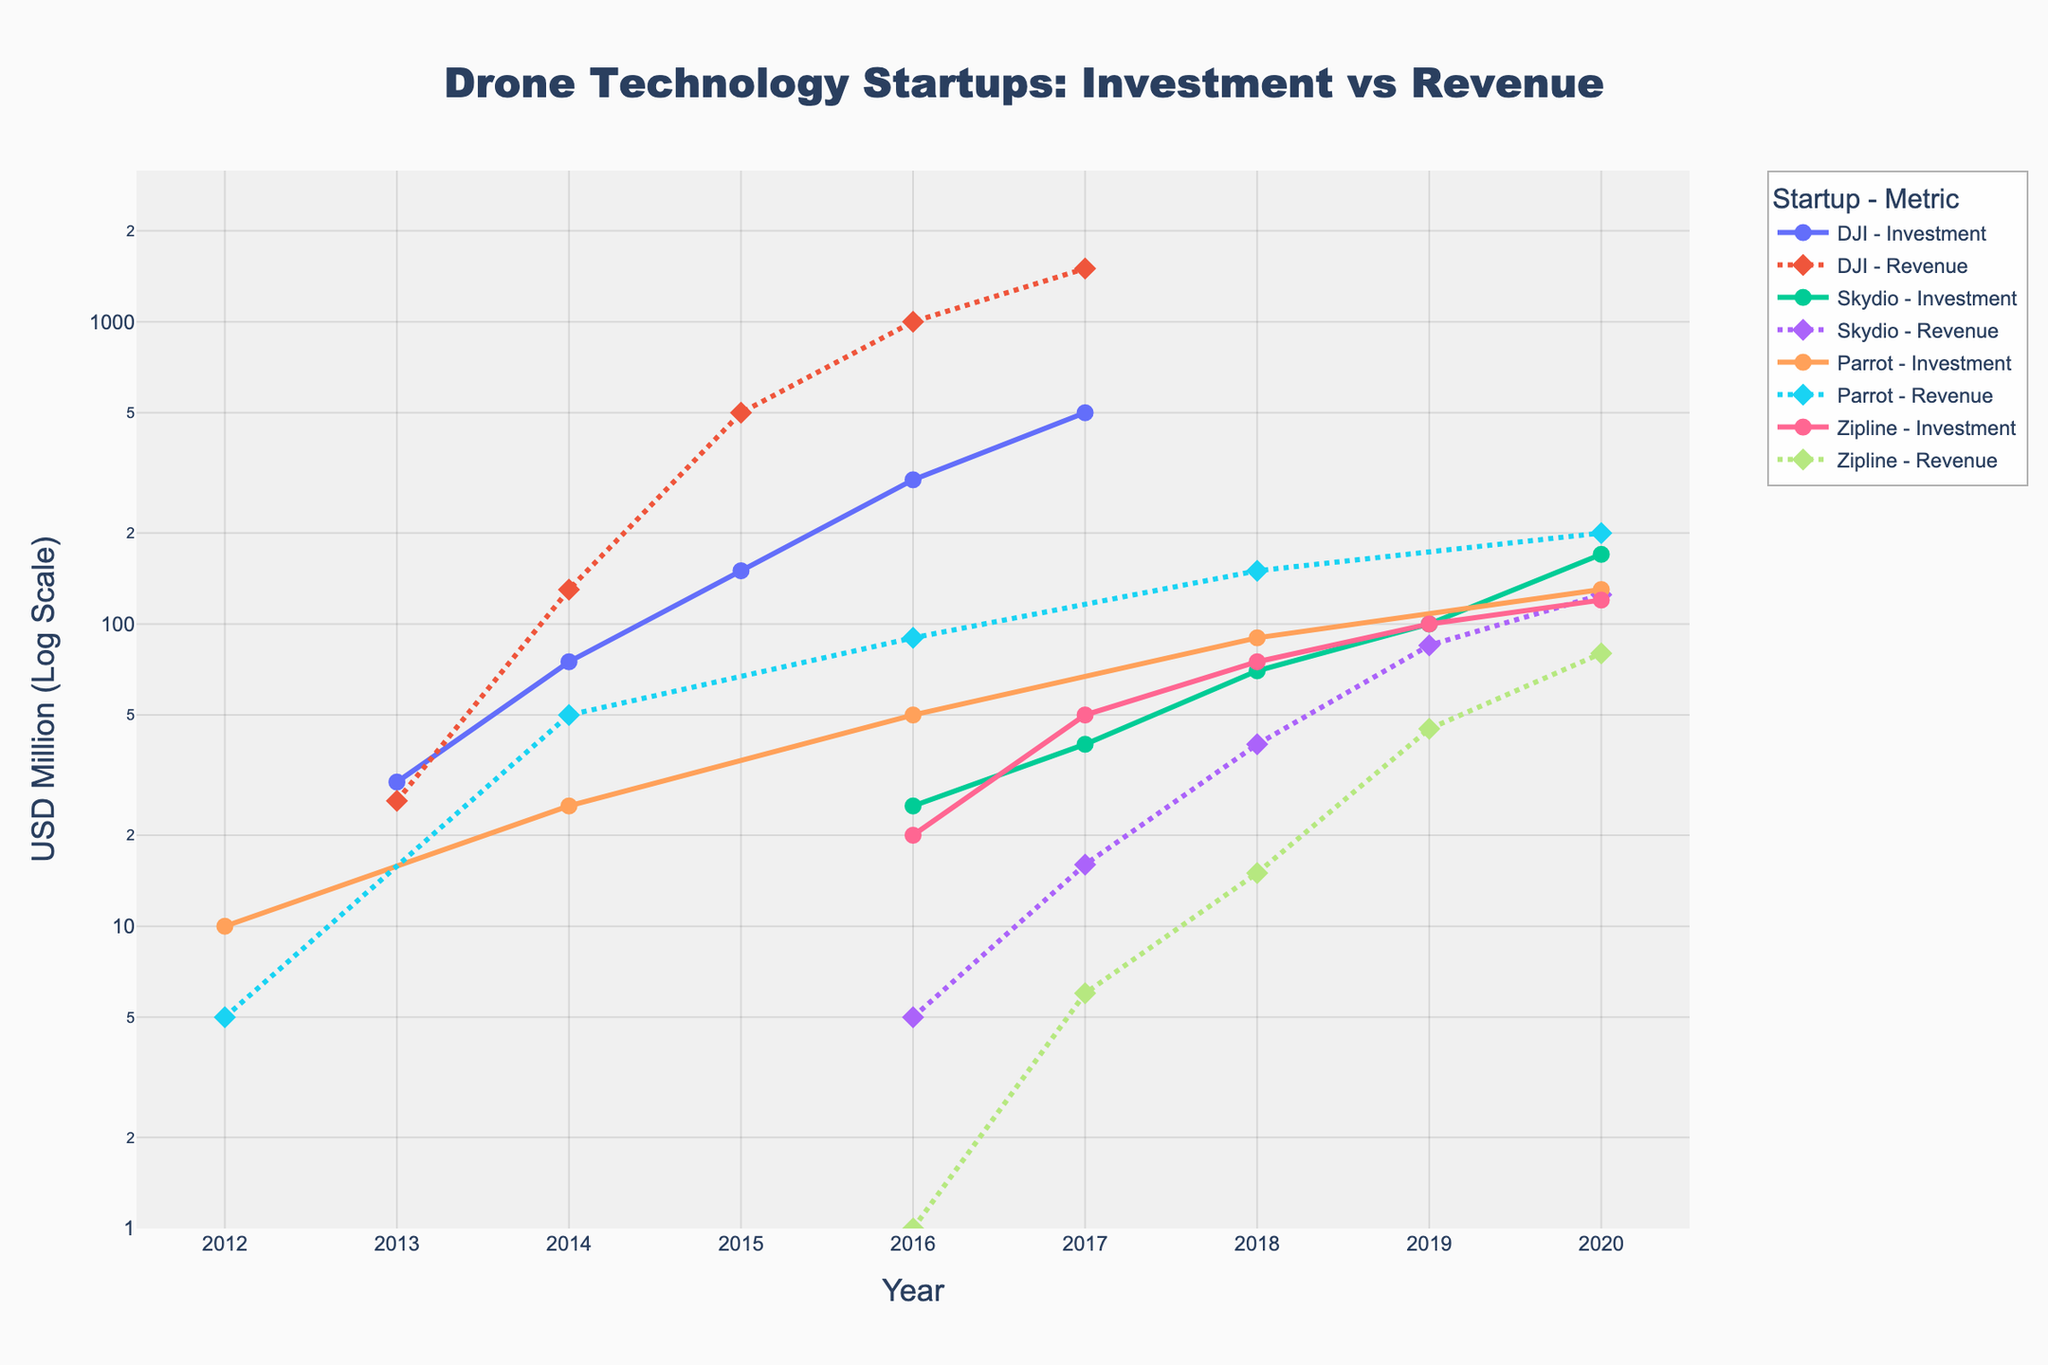what is the title of the plot? The title is displayed at the top of the plot in large, bold text. It reads "Drone Technology Startups: Investment vs Revenue".
Answer: Drone Technology Startups: Investment vs Revenue what is the y-axis label of the plot? The y-axis label is shown vertically along the y-axis and it reads "USD Million (Log Scale)".
Answer: USD Million (Log Scale) which startup had the highest investment in the year 2017? From the plot, looking at the investment lines for each startup, DJI had the highest investment in 2017, indicated by the data point at $500 million.
Answer: DJI how has Skydio's revenue changed from 2016 to 2020? By examining the dashed lines for Skydio, we see that it increased from $5 million in 2016 to $125 million in 2020. The line trends upwards significantly between these years.
Answer: Increased from $5 million to $125 million which startup showed the steadiest growth in both investment and revenue over the years? Observing the smoothness and consistency of the lines for both investment and revenue, Parrot's lines are the most consistent without significant jumps or drops over the years.
Answer: Parrot in what year did Zipline's revenue first exceed $10 million? By looking at the dashed line for Zipline, its revenue first exceeded $10 million in 2018.
Answer: 2018 how did DJI's investment trend between 2013 and 2017? Looking at the solid line for DJI, the investment shows a mostly exponential increase from $30 million in 2013 to $500 million in 2017.
Answer: Exponential increase compare the investment of Skydio and Parrot in 2016. Which startup received more investment, and by how much? Observing the solid lines for 2016, Skydio received $25 million and Parrot received $50 million. Parrot received $25 million more investment than Skydio in 2016.
Answer: Parrot by $25 million does any startup show a decrease in revenue at any point? By looking at all the dashed lines, there is no segment that trends downward, indicating none of the startups show a decrease in revenue at any point.
Answer: No which startup had the highest revenue in 2020 and what was the amount? From the dashed lines for 2020, DJI had the highest revenue, amounting to $1500 million.
Answer: DJI, $1500 million 